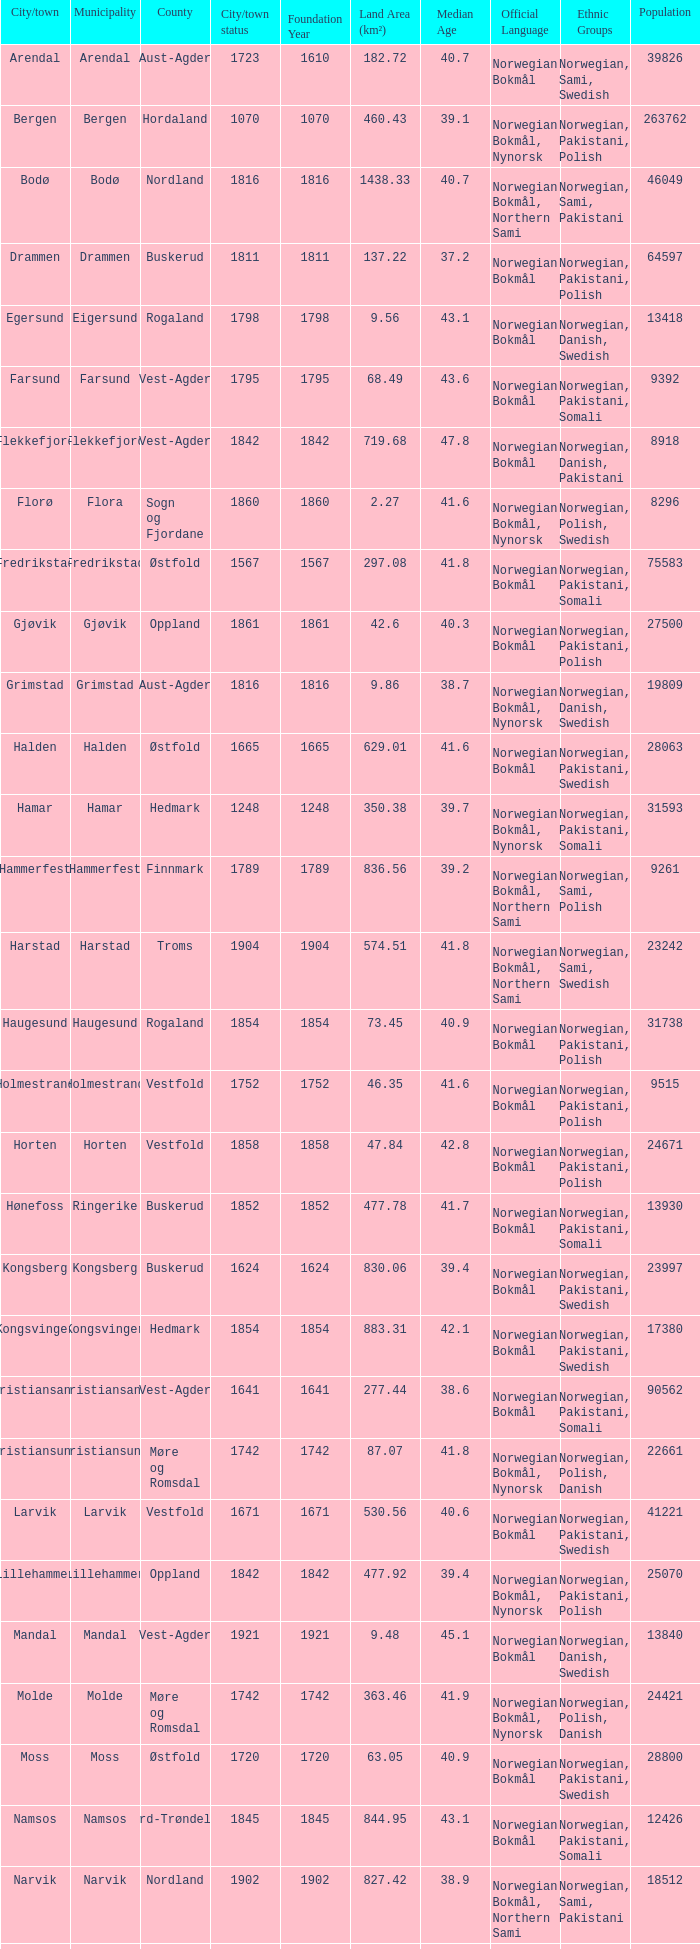Which municipality has a population of 24421? Molde. 